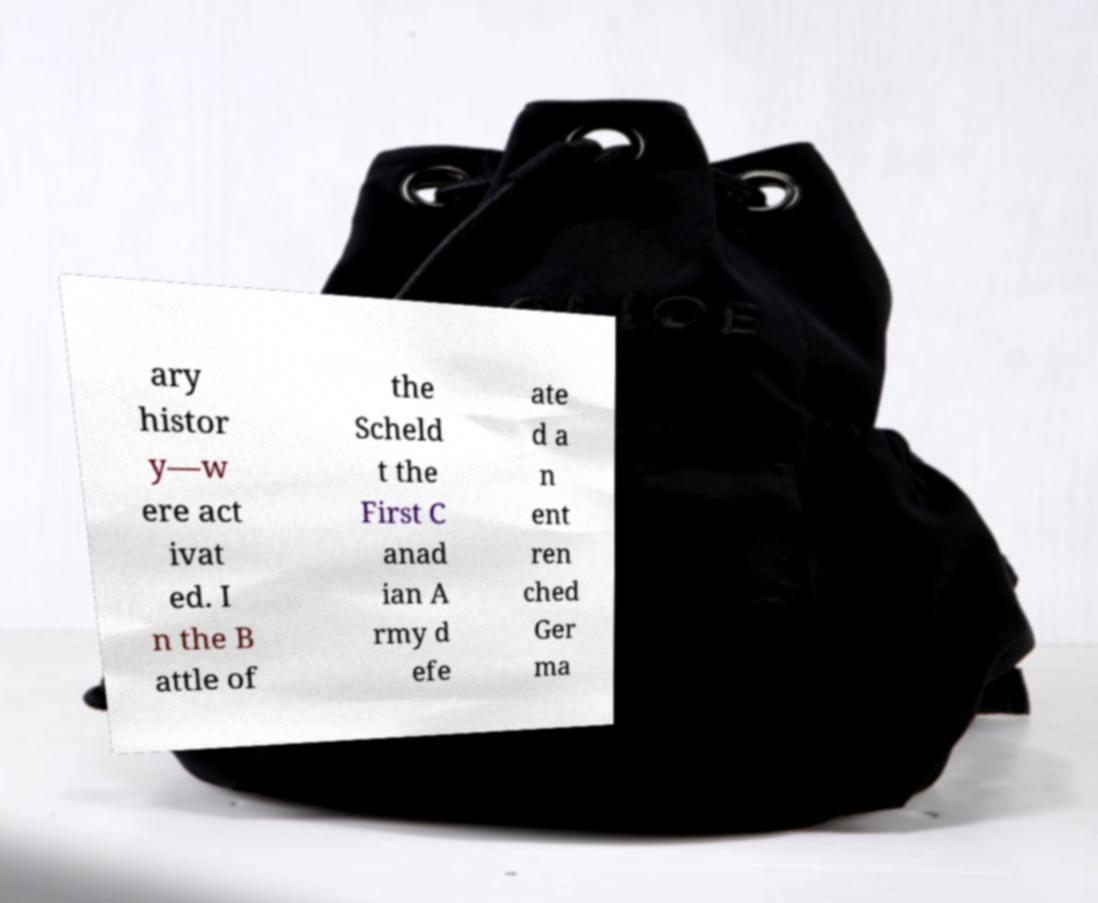Could you extract and type out the text from this image? ary histor y—w ere act ivat ed. I n the B attle of the Scheld t the First C anad ian A rmy d efe ate d a n ent ren ched Ger ma 